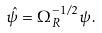Convert formula to latex. <formula><loc_0><loc_0><loc_500><loc_500>\hat { \psi } = \Omega _ { R } ^ { - 1 / 2 } \psi \, .</formula> 